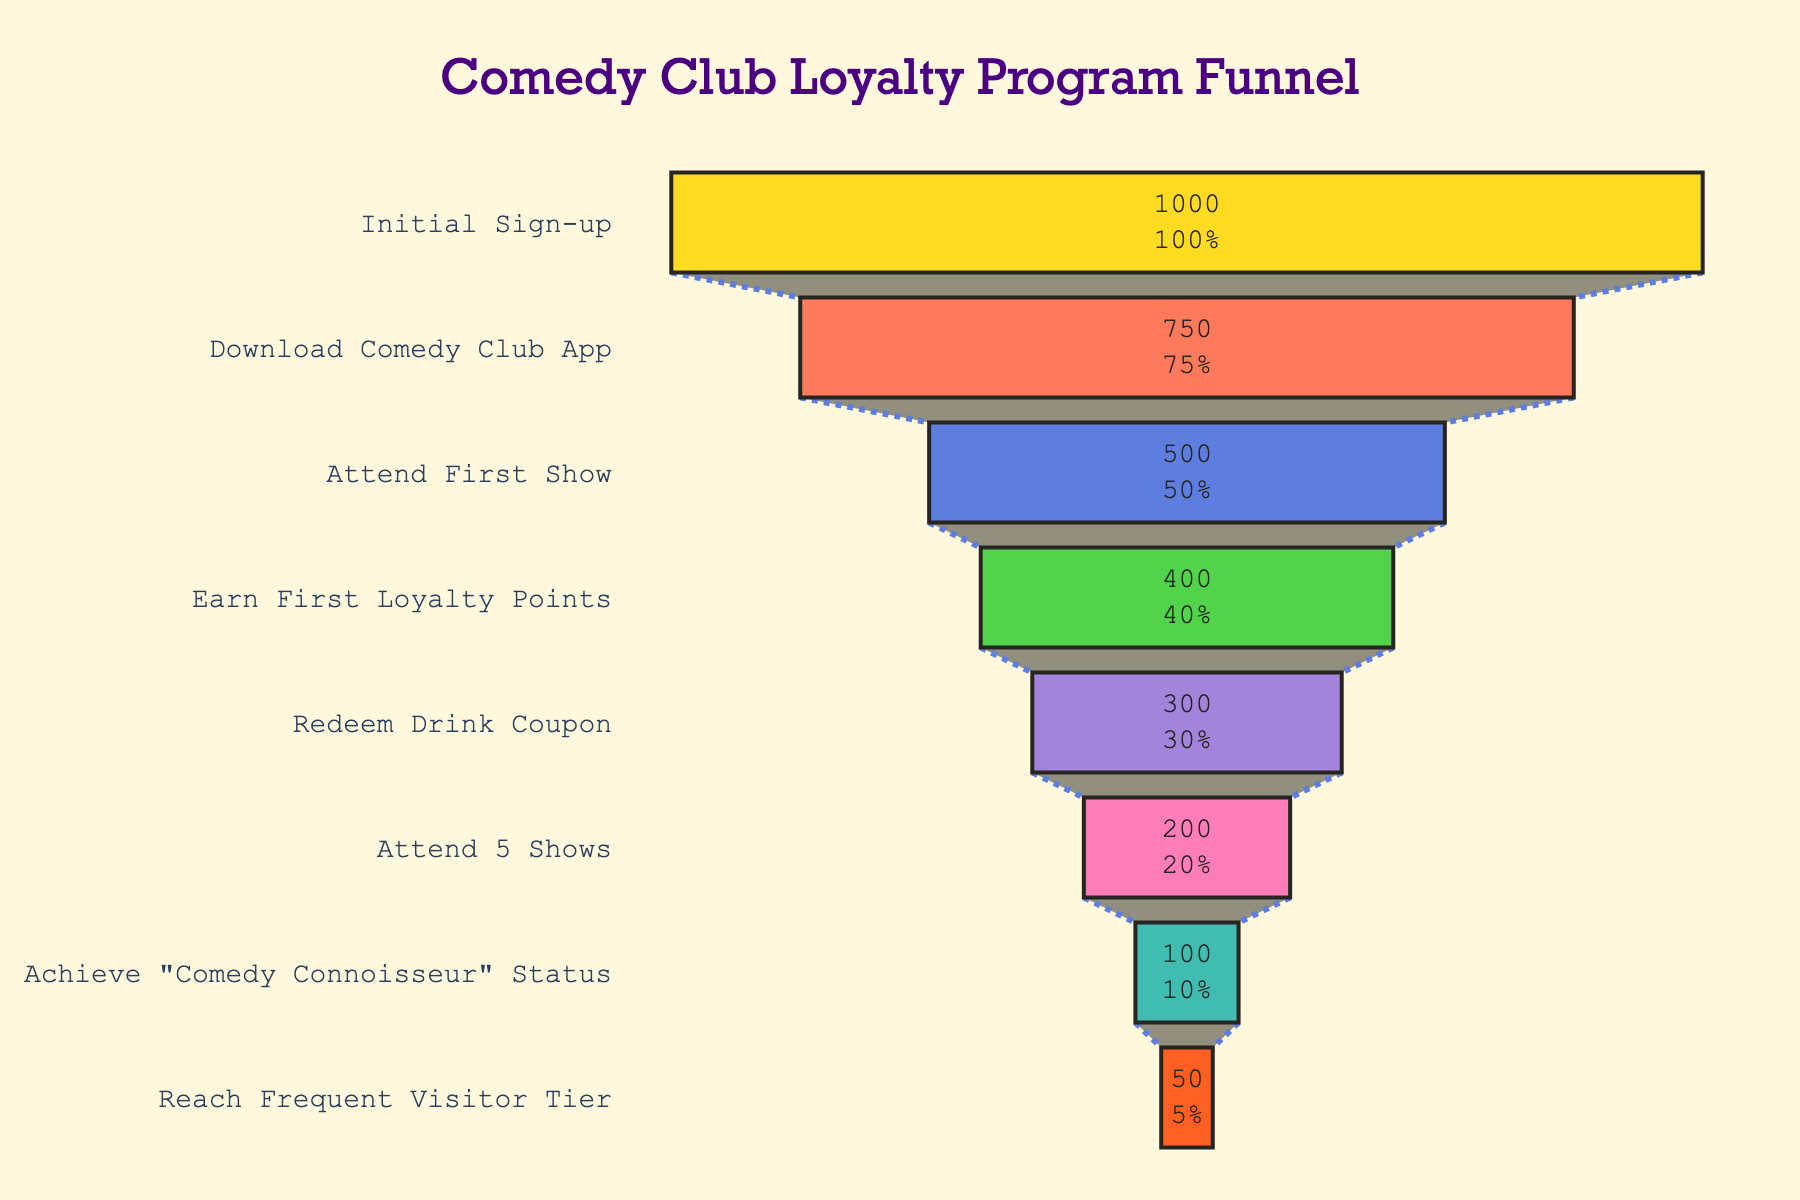what's the title of the funnel chart? The title is typically placed at the top of the chart to describe the visual's content. In this case, it reads "Comedy Club Loyalty Program Funnel."
Answer: Comedy Club Loyalty Program Funnel how many stages are displayed in the funnel chart? You can count the distinct levels shown on the y-axis of the chart. There are eight stages listed from "Initial Sign-up" to "Reach Frequent Visitor Tier."
Answer: 8 what percentage of people who downloaded the comedy club app attended their first show? The chart shows both numbers and percentages. 750 people downloaded the app, and 500 attended their first show. The percentage is calculated as (500/750) * 100.
Answer: 66.67% what's the difference in the number of customers between earning first loyalty points and redeeming a drink coupon? Earning first loyalty points has 400 customers, while redeeming a drink coupon has 300. The difference is calculated as 400 - 300.
Answer: 100 which stage has the highest drop-off compared to its previous stage? By examining the differences between stages, the largest drop is from "Attend First Show" (500) to "Earn First Loyalty Points" (400), which is a drop of 100 customers.
Answer: Attend First Show to Earn First Loyalty Points how many more customers signed up initially compared to those who achieved "Comedy Connoisseur" status? The number of customers at "Initial Sign-up" is 1000, and those who achieved "Comedy Connoisseur" status are 100. The difference is 1000 - 100.
Answer: 900 which stage has half the number of customers compared to "Attend 5 Shows"? "Attend 5 Shows" has 200 customers. "Achieve 'Comedy Connoisseur' Status" has 100 customers, which is exactly half.
Answer: Achieve "Comedy Connoisseur" Status what's the proportion of frequent visitors to those who downloaded the app? 50 customers reached the frequent visitor tier out of 750 who downloaded the app. This is calculated as (50/750) * 100.
Answer: 6.67% what's the smallest percentage of customer retention between any two consecutive stages in the funnel? The smallest percentage change can be checked between every two stages. The smallest retention is from "Achieve 'Comedy Connoisseur' Status" (100) to "Reach Frequent Visitor Tier" (50), which is (50/100) * 100.
Answer: 50% what's the total number of customers at the top three stages of the funnel? The top three stages are "Initial Sign-up" (1000), "Download Comedy Club App" (750), and "Attend First Show" (500). The sum is 1000 + 750 + 500.
Answer: 2250 